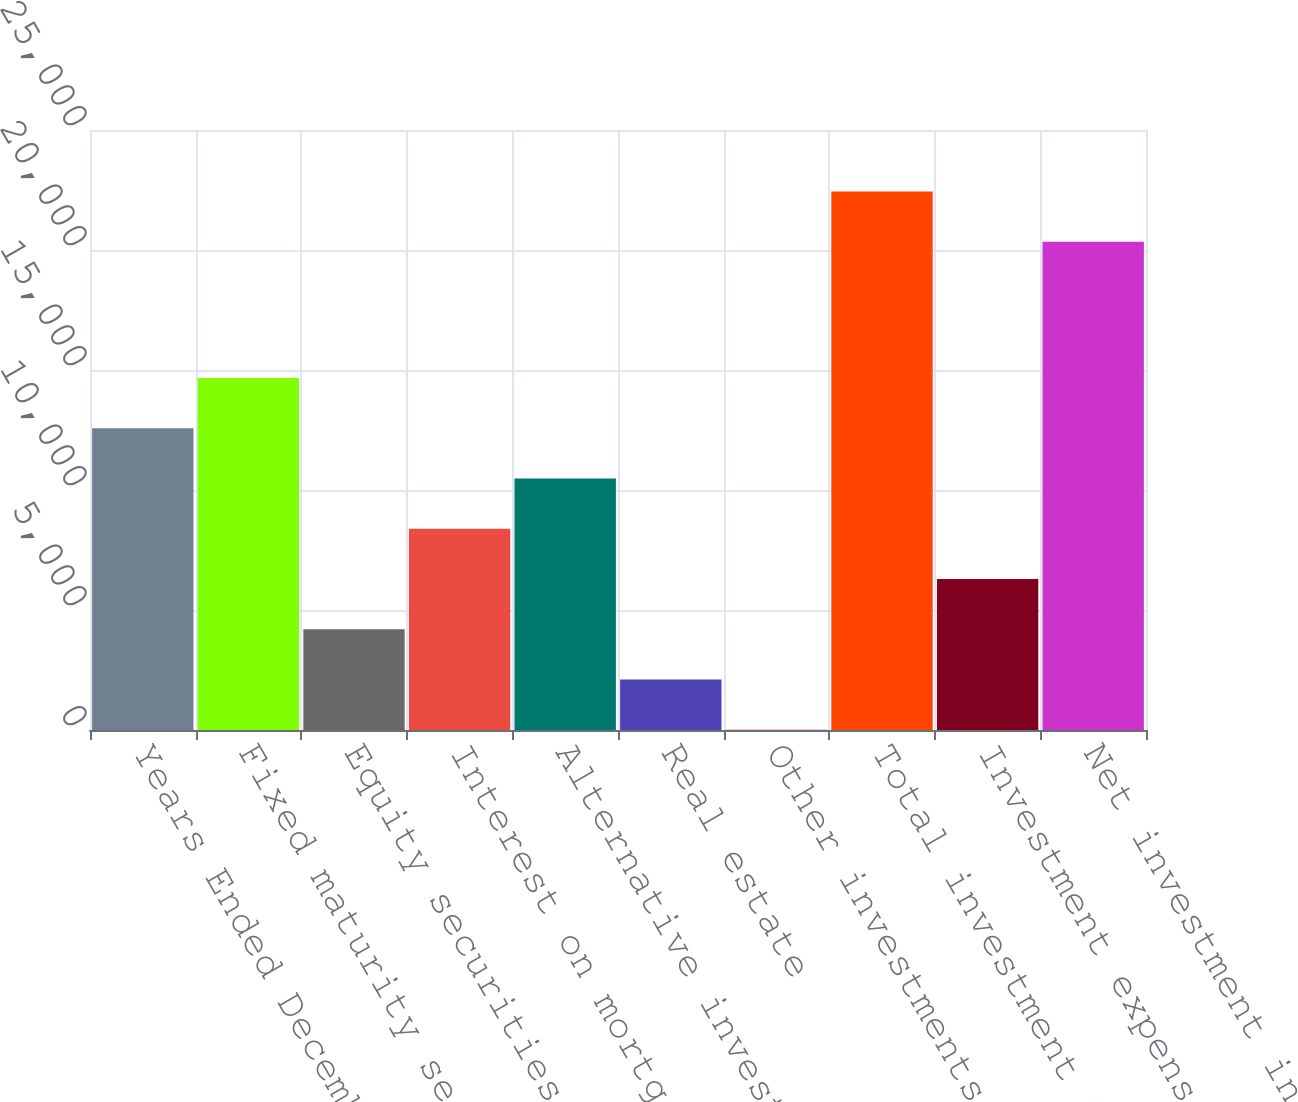<chart> <loc_0><loc_0><loc_500><loc_500><bar_chart><fcel>Years Ended December 31 (in<fcel>Fixed maturity securities<fcel>Equity securities<fcel>Interest on mortgage and other<fcel>Alternative investments^<fcel>Real estate<fcel>Other investments<fcel>Total investment income<fcel>Investment expenses<fcel>Net investment income<nl><fcel>12572.6<fcel>14666.2<fcel>4198.2<fcel>8385.4<fcel>10479<fcel>2104.6<fcel>11<fcel>22436.6<fcel>6291.8<fcel>20343<nl></chart> 